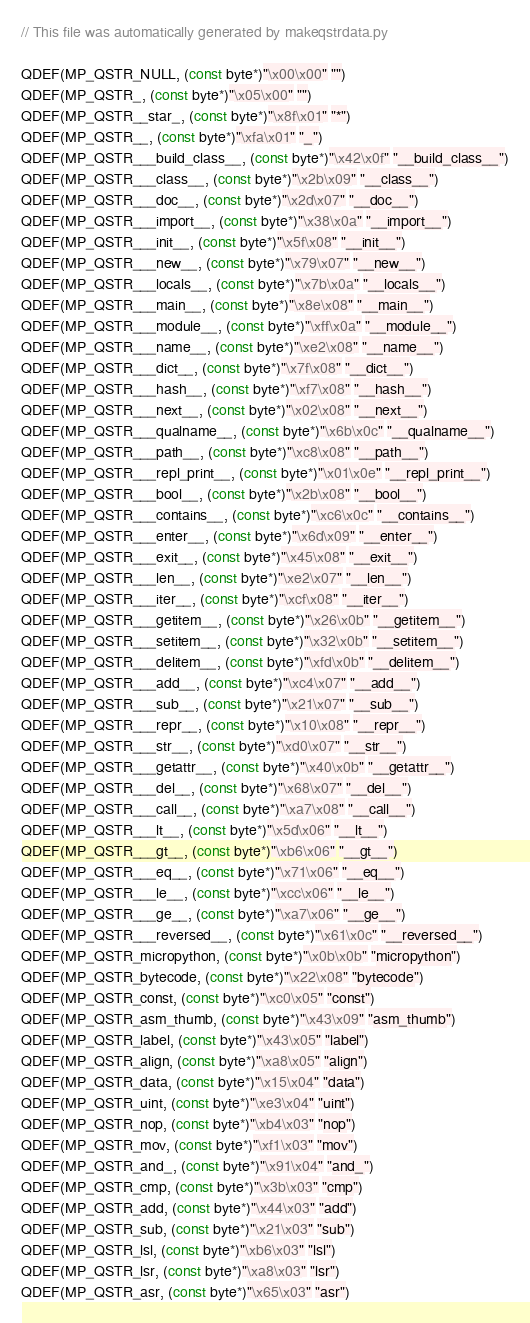<code> <loc_0><loc_0><loc_500><loc_500><_C_>// This file was automatically generated by makeqstrdata.py

QDEF(MP_QSTR_NULL, (const byte*)"\x00\x00" "")
QDEF(MP_QSTR_, (const byte*)"\x05\x00" "")
QDEF(MP_QSTR__star_, (const byte*)"\x8f\x01" "*")
QDEF(MP_QSTR__, (const byte*)"\xfa\x01" "_")
QDEF(MP_QSTR___build_class__, (const byte*)"\x42\x0f" "__build_class__")
QDEF(MP_QSTR___class__, (const byte*)"\x2b\x09" "__class__")
QDEF(MP_QSTR___doc__, (const byte*)"\x2d\x07" "__doc__")
QDEF(MP_QSTR___import__, (const byte*)"\x38\x0a" "__import__")
QDEF(MP_QSTR___init__, (const byte*)"\x5f\x08" "__init__")
QDEF(MP_QSTR___new__, (const byte*)"\x79\x07" "__new__")
QDEF(MP_QSTR___locals__, (const byte*)"\x7b\x0a" "__locals__")
QDEF(MP_QSTR___main__, (const byte*)"\x8e\x08" "__main__")
QDEF(MP_QSTR___module__, (const byte*)"\xff\x0a" "__module__")
QDEF(MP_QSTR___name__, (const byte*)"\xe2\x08" "__name__")
QDEF(MP_QSTR___dict__, (const byte*)"\x7f\x08" "__dict__")
QDEF(MP_QSTR___hash__, (const byte*)"\xf7\x08" "__hash__")
QDEF(MP_QSTR___next__, (const byte*)"\x02\x08" "__next__")
QDEF(MP_QSTR___qualname__, (const byte*)"\x6b\x0c" "__qualname__")
QDEF(MP_QSTR___path__, (const byte*)"\xc8\x08" "__path__")
QDEF(MP_QSTR___repl_print__, (const byte*)"\x01\x0e" "__repl_print__")
QDEF(MP_QSTR___bool__, (const byte*)"\x2b\x08" "__bool__")
QDEF(MP_QSTR___contains__, (const byte*)"\xc6\x0c" "__contains__")
QDEF(MP_QSTR___enter__, (const byte*)"\x6d\x09" "__enter__")
QDEF(MP_QSTR___exit__, (const byte*)"\x45\x08" "__exit__")
QDEF(MP_QSTR___len__, (const byte*)"\xe2\x07" "__len__")
QDEF(MP_QSTR___iter__, (const byte*)"\xcf\x08" "__iter__")
QDEF(MP_QSTR___getitem__, (const byte*)"\x26\x0b" "__getitem__")
QDEF(MP_QSTR___setitem__, (const byte*)"\x32\x0b" "__setitem__")
QDEF(MP_QSTR___delitem__, (const byte*)"\xfd\x0b" "__delitem__")
QDEF(MP_QSTR___add__, (const byte*)"\xc4\x07" "__add__")
QDEF(MP_QSTR___sub__, (const byte*)"\x21\x07" "__sub__")
QDEF(MP_QSTR___repr__, (const byte*)"\x10\x08" "__repr__")
QDEF(MP_QSTR___str__, (const byte*)"\xd0\x07" "__str__")
QDEF(MP_QSTR___getattr__, (const byte*)"\x40\x0b" "__getattr__")
QDEF(MP_QSTR___del__, (const byte*)"\x68\x07" "__del__")
QDEF(MP_QSTR___call__, (const byte*)"\xa7\x08" "__call__")
QDEF(MP_QSTR___lt__, (const byte*)"\x5d\x06" "__lt__")
QDEF(MP_QSTR___gt__, (const byte*)"\xb6\x06" "__gt__")
QDEF(MP_QSTR___eq__, (const byte*)"\x71\x06" "__eq__")
QDEF(MP_QSTR___le__, (const byte*)"\xcc\x06" "__le__")
QDEF(MP_QSTR___ge__, (const byte*)"\xa7\x06" "__ge__")
QDEF(MP_QSTR___reversed__, (const byte*)"\x61\x0c" "__reversed__")
QDEF(MP_QSTR_micropython, (const byte*)"\x0b\x0b" "micropython")
QDEF(MP_QSTR_bytecode, (const byte*)"\x22\x08" "bytecode")
QDEF(MP_QSTR_const, (const byte*)"\xc0\x05" "const")
QDEF(MP_QSTR_asm_thumb, (const byte*)"\x43\x09" "asm_thumb")
QDEF(MP_QSTR_label, (const byte*)"\x43\x05" "label")
QDEF(MP_QSTR_align, (const byte*)"\xa8\x05" "align")
QDEF(MP_QSTR_data, (const byte*)"\x15\x04" "data")
QDEF(MP_QSTR_uint, (const byte*)"\xe3\x04" "uint")
QDEF(MP_QSTR_nop, (const byte*)"\xb4\x03" "nop")
QDEF(MP_QSTR_mov, (const byte*)"\xf1\x03" "mov")
QDEF(MP_QSTR_and_, (const byte*)"\x91\x04" "and_")
QDEF(MP_QSTR_cmp, (const byte*)"\x3b\x03" "cmp")
QDEF(MP_QSTR_add, (const byte*)"\x44\x03" "add")
QDEF(MP_QSTR_sub, (const byte*)"\x21\x03" "sub")
QDEF(MP_QSTR_lsl, (const byte*)"\xb6\x03" "lsl")
QDEF(MP_QSTR_lsr, (const byte*)"\xa8\x03" "lsr")
QDEF(MP_QSTR_asr, (const byte*)"\x65\x03" "asr")</code> 